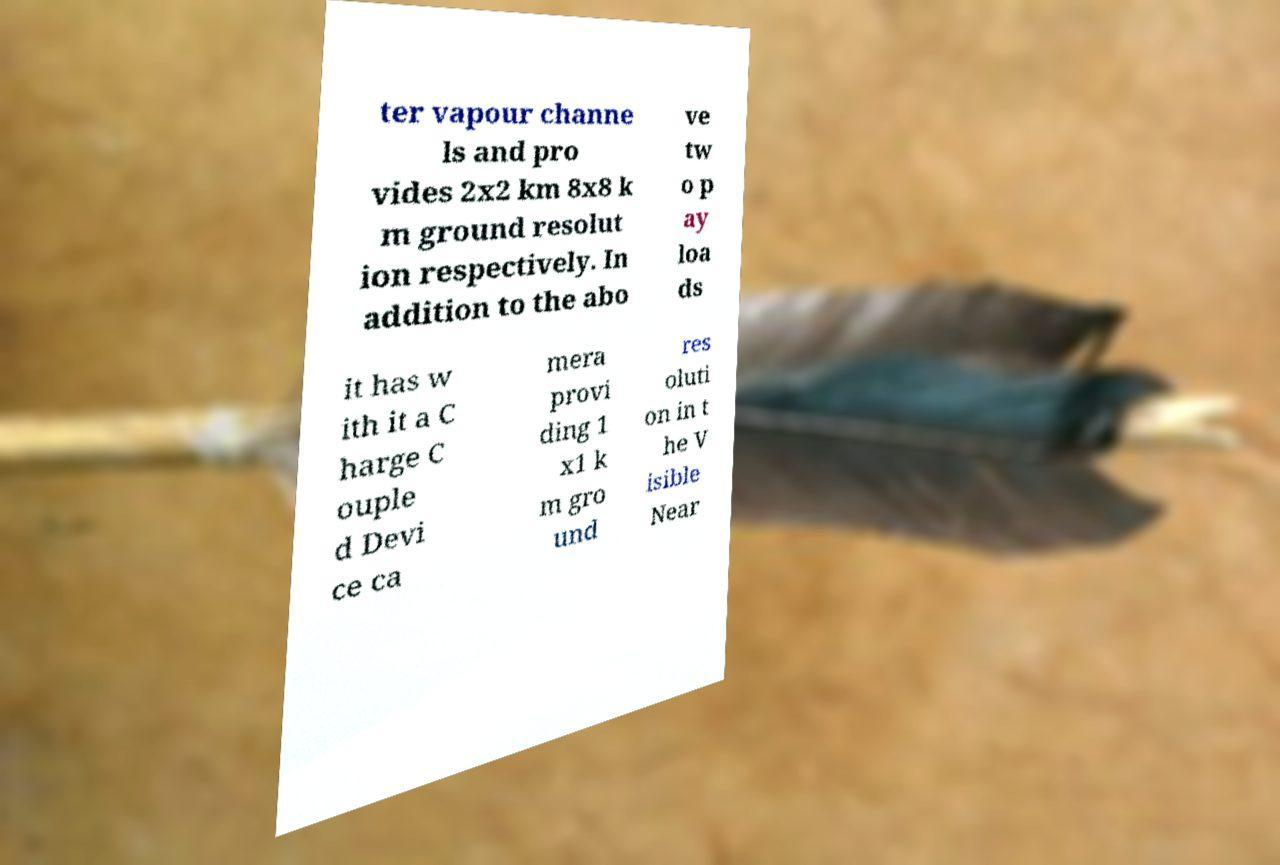There's text embedded in this image that I need extracted. Can you transcribe it verbatim? ter vapour channe ls and pro vides 2x2 km 8x8 k m ground resolut ion respectively. In addition to the abo ve tw o p ay loa ds it has w ith it a C harge C ouple d Devi ce ca mera provi ding 1 x1 k m gro und res oluti on in t he V isible Near 